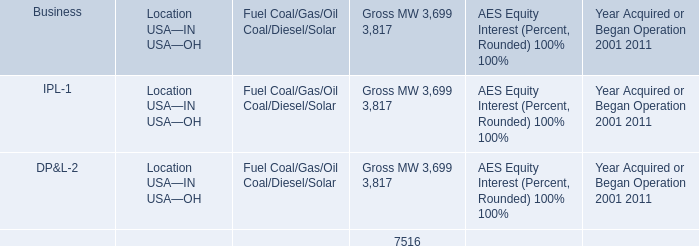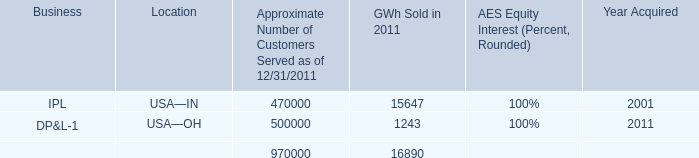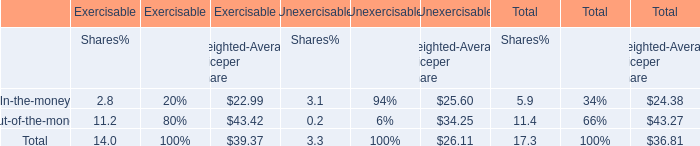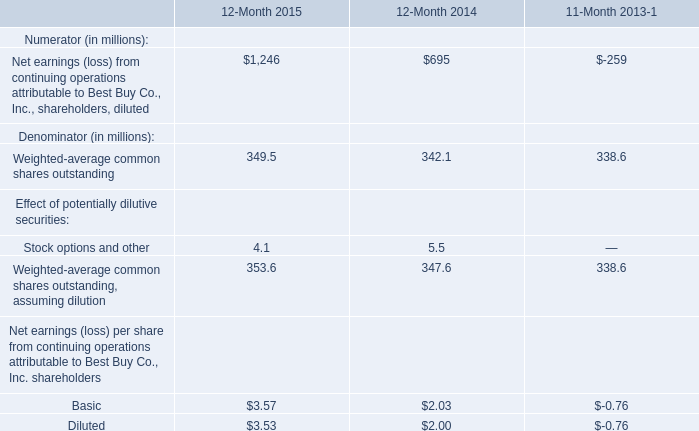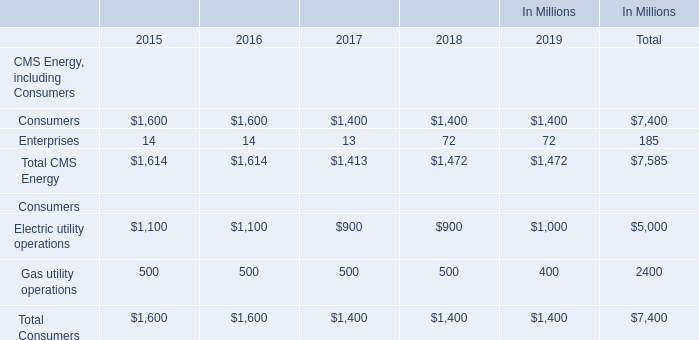What is the average amount of IPL of GWh Sold in 2011, and Electric utility operations Consumers of data 0 2015 ? 
Computations: ((15647.0 + 1100.0) / 2)
Answer: 8373.5. 